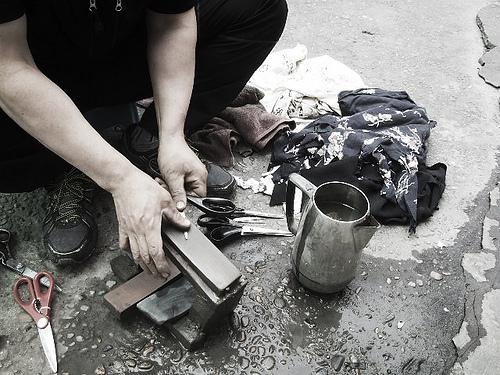Question: how many people in the photo?
Choices:
A. One.
B. Two.
C. Three.
D. Four.
Answer with the letter. Answer: A Question: what color is the container?
Choices:
A. Clear.
B. White.
C. Silver.
D. Yellow.
Answer with the letter. Answer: C Question: why is it so bright?
Choices:
A. Headlights on the highway.
B. Sunny.
C. It is high noon.
D. They are at the equator.
Answer with the letter. Answer: B Question: who is in the photo?
Choices:
A. A man.
B. A person.
C. A salesman.
D. A pedestrian.
Answer with the letter. Answer: A Question: where was the photo taken?
Choices:
A. On the curb.
B. On the street.
C. On the sidewalk.
D. On the railroad tracks.
Answer with the letter. Answer: B 